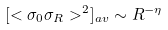<formula> <loc_0><loc_0><loc_500><loc_500>[ < \sigma _ { 0 } \sigma _ { R } > ^ { 2 } ] _ { a v } \sim R ^ { - \eta }</formula> 